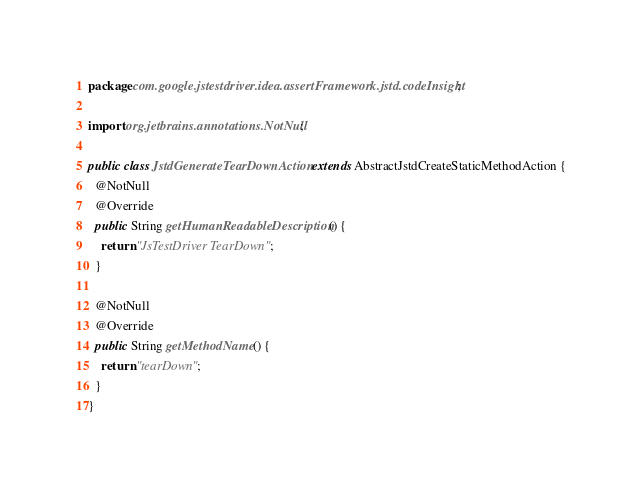Convert code to text. <code><loc_0><loc_0><loc_500><loc_500><_Java_>package com.google.jstestdriver.idea.assertFramework.jstd.codeInsight;

import org.jetbrains.annotations.NotNull;

public class JstdGenerateTearDownAction extends AbstractJstdCreateStaticMethodAction {
  @NotNull
  @Override
  public String getHumanReadableDescription() {
    return "JsTestDriver TearDown";
  }

  @NotNull
  @Override
  public String getMethodName() {
    return "tearDown";
  }
}
</code> 